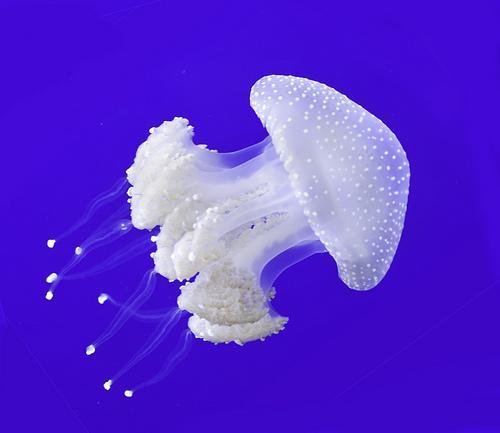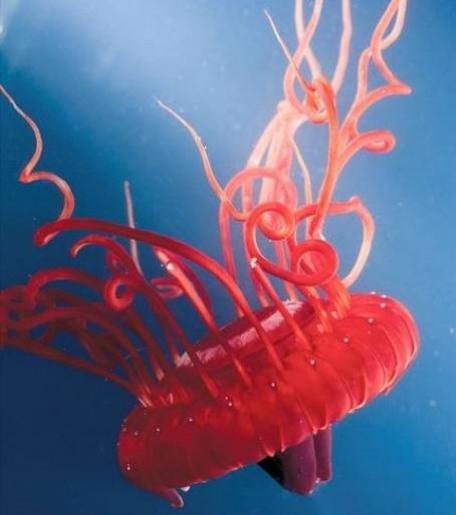The first image is the image on the left, the second image is the image on the right. Analyze the images presented: Is the assertion "An image shows a white jellyfish with its 'mushroom cap' heading rightward." valid? Answer yes or no. Yes. The first image is the image on the left, the second image is the image on the right. Given the left and right images, does the statement "A single white jellyfish is traveling towards the right in one of the images." hold true? Answer yes or no. Yes. 